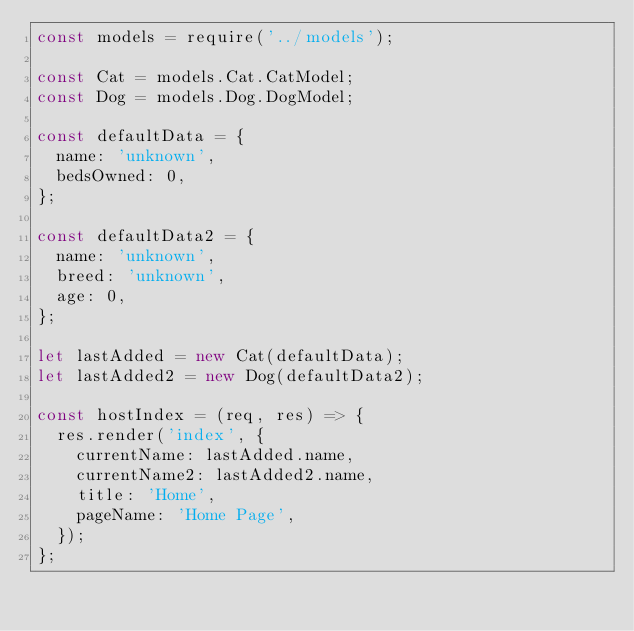<code> <loc_0><loc_0><loc_500><loc_500><_JavaScript_>const models = require('../models');

const Cat = models.Cat.CatModel;
const Dog = models.Dog.DogModel;

const defaultData = {
  name: 'unknown',
  bedsOwned: 0,
};

const defaultData2 = {
  name: 'unknown',
  breed: 'unknown',
  age: 0,
};

let lastAdded = new Cat(defaultData);
let lastAdded2 = new Dog(defaultData2);

const hostIndex = (req, res) => {
  res.render('index', {
    currentName: lastAdded.name,
    currentName2: lastAdded2.name,
    title: 'Home',
    pageName: 'Home Page',
  });
};
</code> 